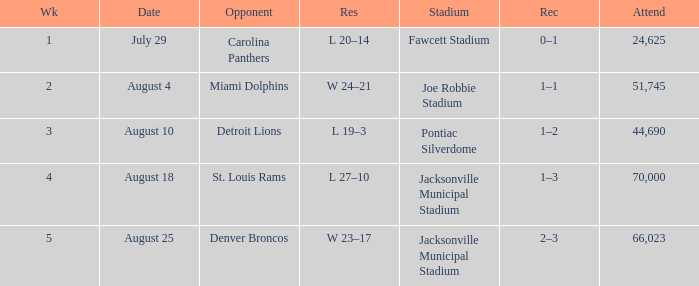What is the Record in Week 2? 1–1. 